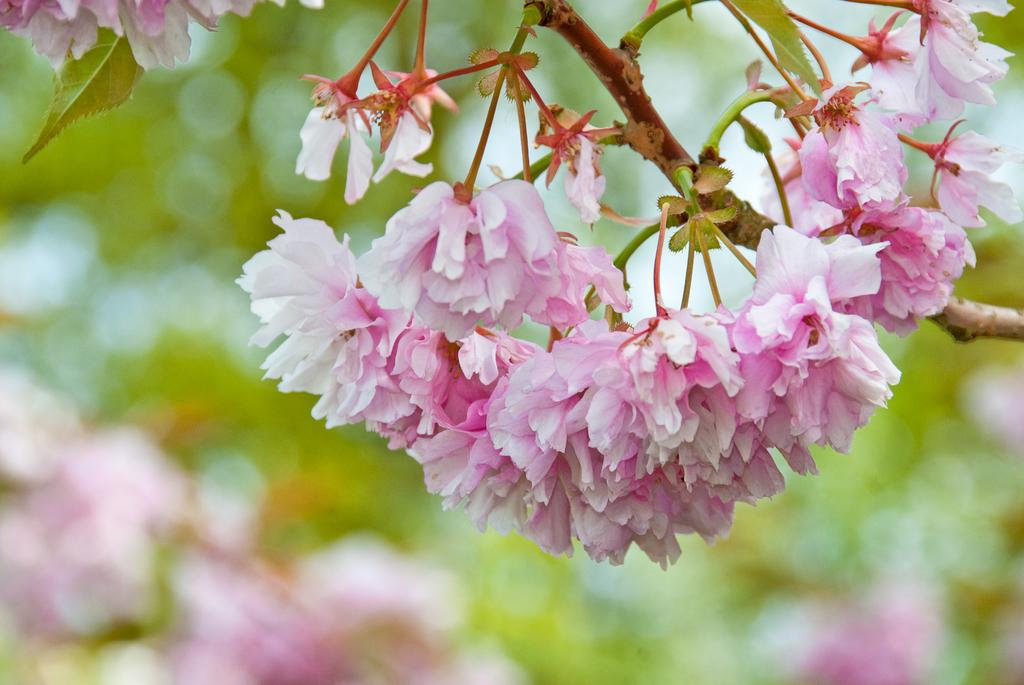What is the main subject of the image? The main subject of the image is a tree with many flowers on it. Can you describe the background of the image? The background of the image is blurred. How many balls are visible in the image? There are no balls present in the image. What type of dolls can be seen playing with the flowers in the image? There are no dolls present in the image, and the flowers are on a tree, not being played with. 